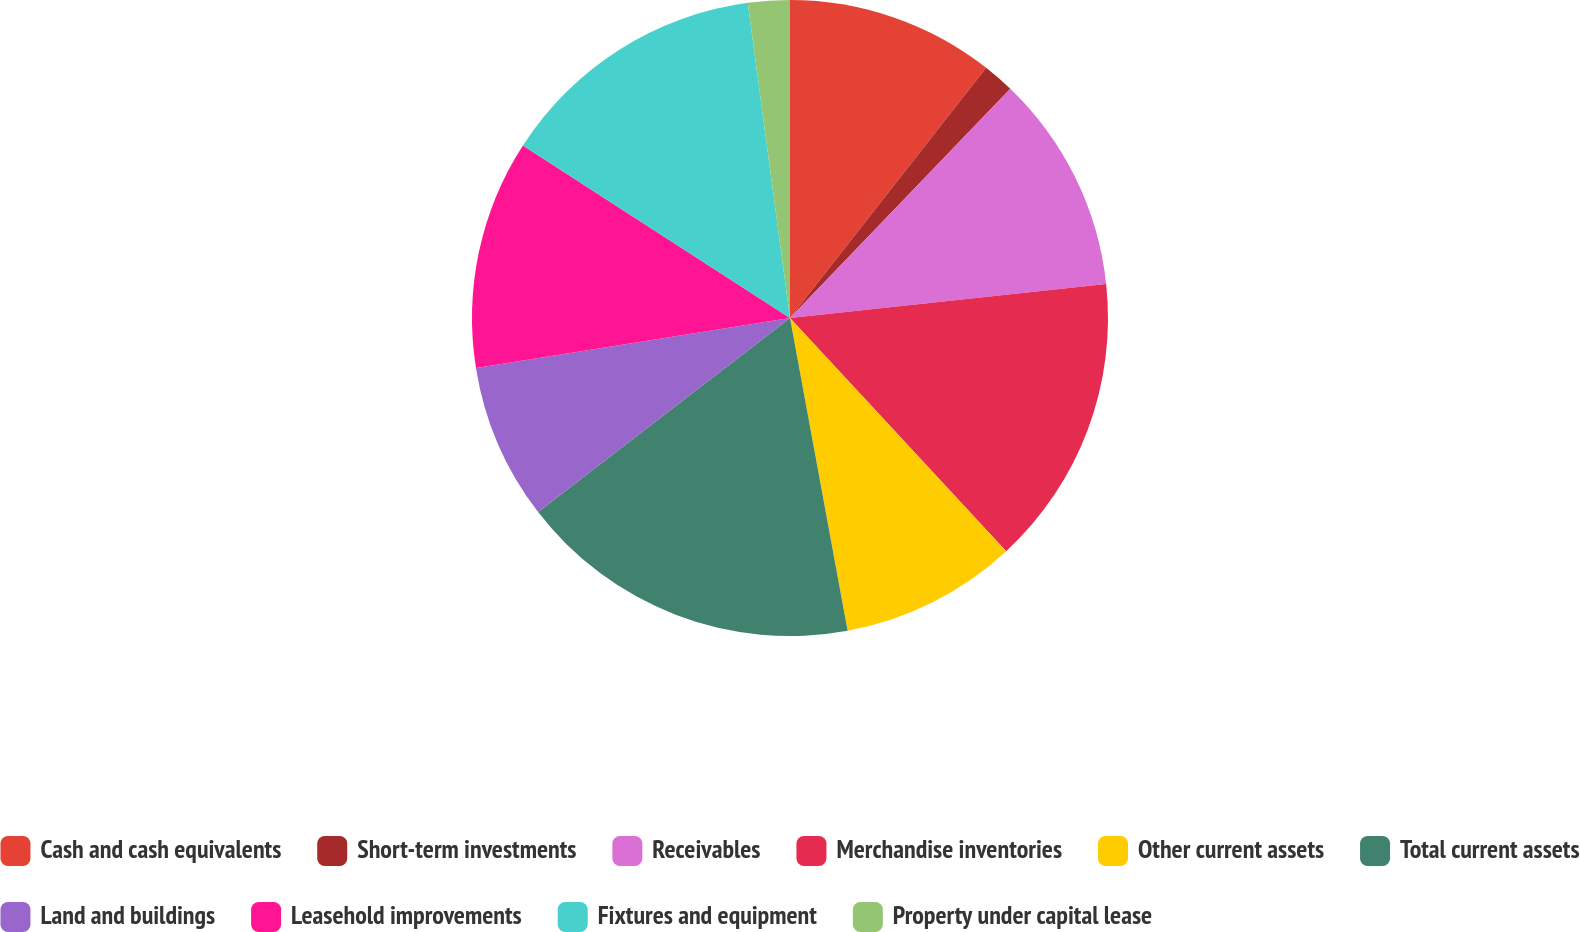Convert chart to OTSL. <chart><loc_0><loc_0><loc_500><loc_500><pie_chart><fcel>Cash and cash equivalents<fcel>Short-term investments<fcel>Receivables<fcel>Merchandise inventories<fcel>Other current assets<fcel>Total current assets<fcel>Land and buildings<fcel>Leasehold improvements<fcel>Fixtures and equipment<fcel>Property under capital lease<nl><fcel>10.58%<fcel>1.6%<fcel>11.11%<fcel>14.81%<fcel>9.0%<fcel>17.45%<fcel>7.94%<fcel>11.64%<fcel>13.75%<fcel>2.12%<nl></chart> 